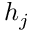Convert formula to latex. <formula><loc_0><loc_0><loc_500><loc_500>h _ { j }</formula> 